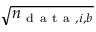<formula> <loc_0><loc_0><loc_500><loc_500>\sqrt { n _ { d a t a , i , b } }</formula> 